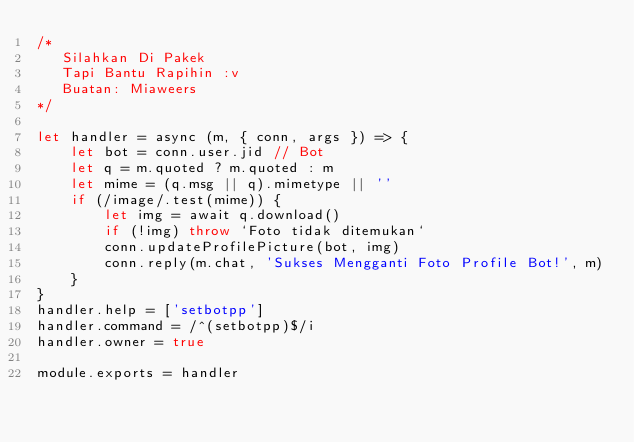<code> <loc_0><loc_0><loc_500><loc_500><_JavaScript_>/*
   Silahkan Di Pakek
   Tapi Bantu Rapihin :v
   Buatan: Miaweers
*/

let handler = async (m, { conn, args }) => {
    let bot = conn.user.jid // Bot
    let q = m.quoted ? m.quoted : m
    let mime = (q.msg || q).mimetype || ''
    if (/image/.test(mime)) {
        let img = await q.download()
        if (!img) throw `Foto tidak ditemukan`
        conn.updateProfilePicture(bot, img)
        conn.reply(m.chat, 'Sukses Mengganti Foto Profile Bot!', m)
    }
}
handler.help = ['setbotpp']
handler.command = /^(setbotpp)$/i
handler.owner = true

module.exports = handler
</code> 